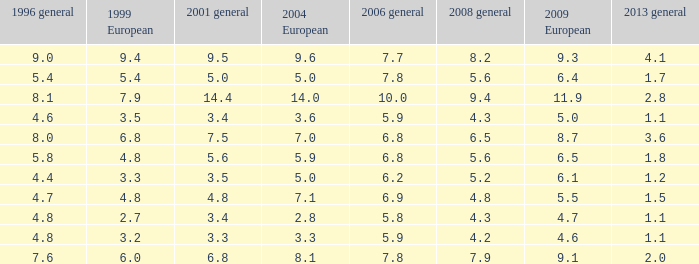Can you give me this table as a dict? {'header': ['1996 general', '1999 European', '2001 general', '2004 European', '2006 general', '2008 general', '2009 European', '2013 general'], 'rows': [['9.0', '9.4', '9.5', '9.6', '7.7', '8.2', '9.3', '4.1'], ['5.4', '5.4', '5.0', '5.0', '7.8', '5.6', '6.4', '1.7'], ['8.1', '7.9', '14.4', '14.0', '10.0', '9.4', '11.9', '2.8'], ['4.6', '3.5', '3.4', '3.6', '5.9', '4.3', '5.0', '1.1'], ['8.0', '6.8', '7.5', '7.0', '6.8', '6.5', '8.7', '3.6'], ['5.8', '4.8', '5.6', '5.9', '6.8', '5.6', '6.5', '1.8'], ['4.4', '3.3', '3.5', '5.0', '6.2', '5.2', '6.1', '1.2'], ['4.7', '4.8', '4.8', '7.1', '6.9', '4.8', '5.5', '1.5'], ['4.8', '2.7', '3.4', '2.8', '5.8', '4.3', '4.7', '1.1'], ['4.8', '3.2', '3.3', '3.3', '5.9', '4.2', '4.6', '1.1'], ['7.6', '6.0', '6.8', '8.1', '7.8', '7.9', '9.1', '2.0']]} What was the value for 2004 European with less than 7.5 in general 2001, less than 6.4 in 2009 European, and less than 1.5 in general 2013 with 4.3 in 2008 general? 3.6, 2.8. 